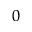Convert formula to latex. <formula><loc_0><loc_0><loc_500><loc_500>_ { 0 }</formula> 